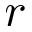Convert formula to latex. <formula><loc_0><loc_0><loc_500><loc_500>r</formula> 